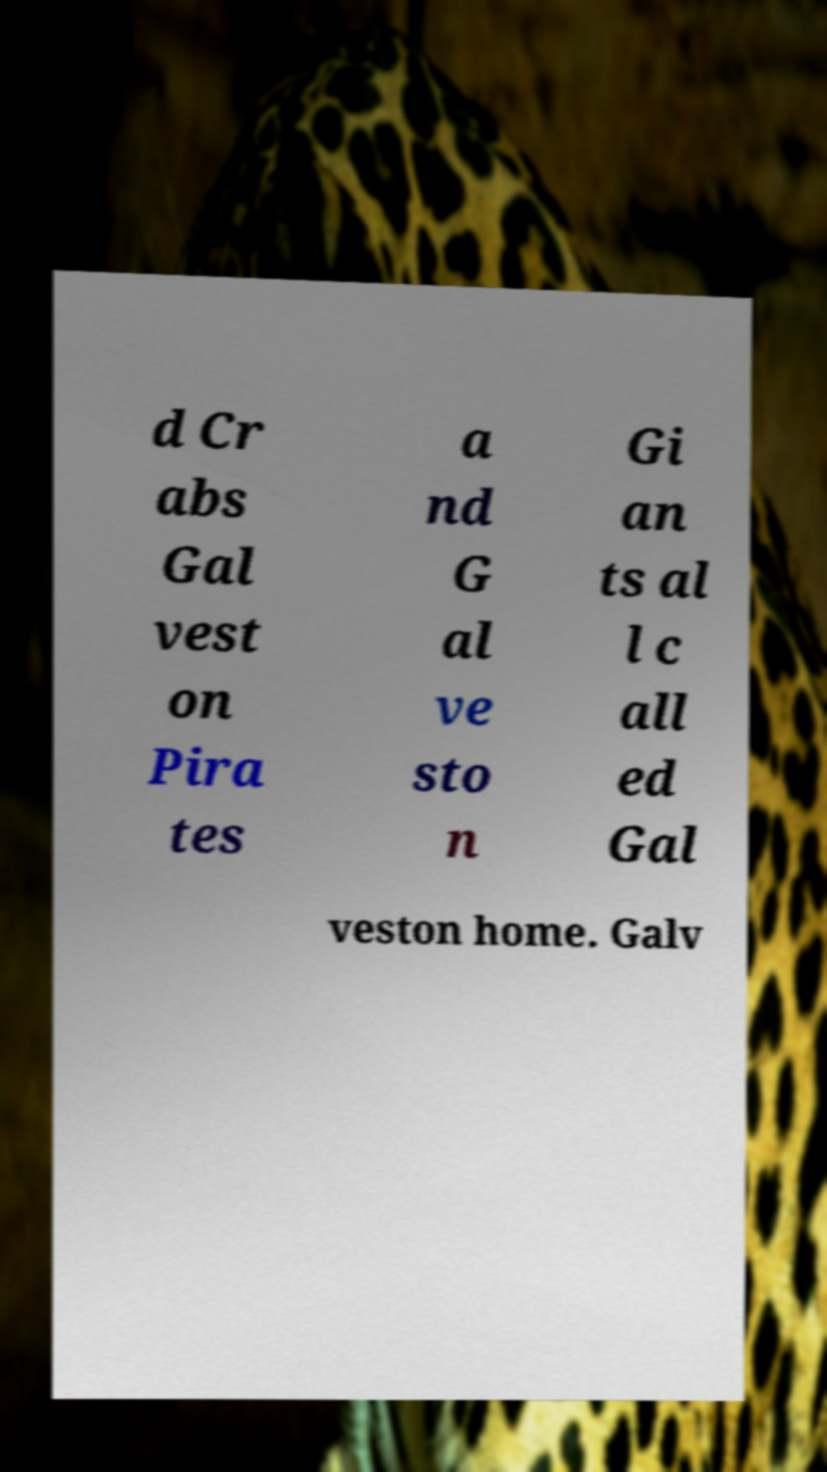Can you read and provide the text displayed in the image?This photo seems to have some interesting text. Can you extract and type it out for me? d Cr abs Gal vest on Pira tes a nd G al ve sto n Gi an ts al l c all ed Gal veston home. Galv 